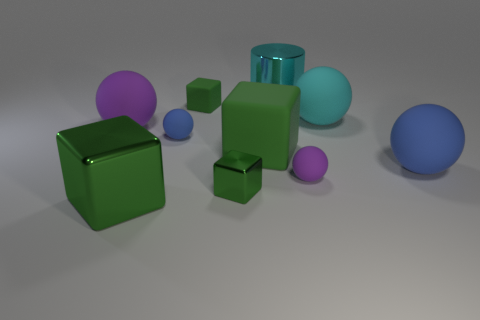Subtract all green cubes. How many were subtracted if there are1green cubes left? 3 Subtract all purple rubber spheres. How many spheres are left? 3 Subtract all cyan balls. How many balls are left? 4 Subtract 4 spheres. How many spheres are left? 1 Subtract all blue cylinders. How many blue spheres are left? 2 Subtract all blocks. How many objects are left? 6 Subtract all yellow cylinders. Subtract all green spheres. How many cylinders are left? 1 Subtract all big green blocks. Subtract all cyan metal cylinders. How many objects are left? 7 Add 9 tiny metal things. How many tiny metal things are left? 10 Add 4 big cyan matte objects. How many big cyan matte objects exist? 5 